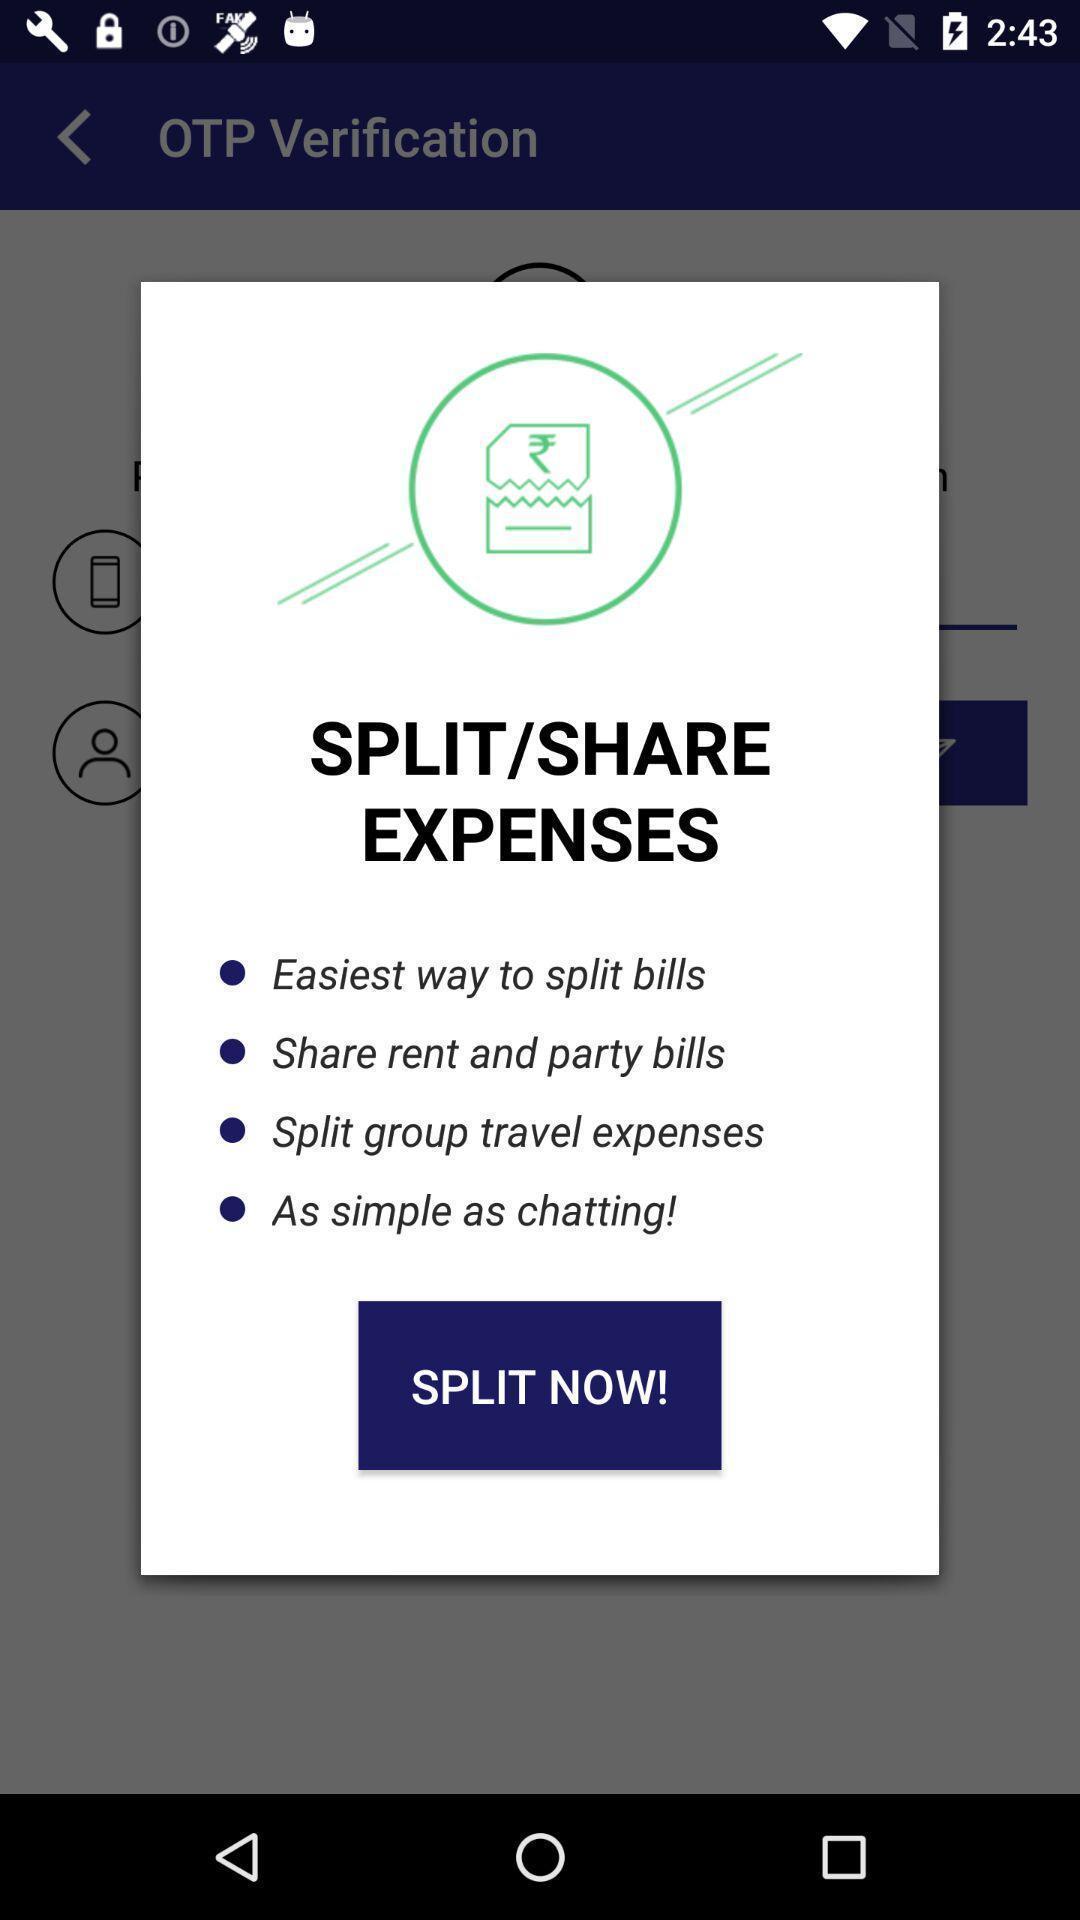Give me a summary of this screen capture. Pop-up showing split now. 